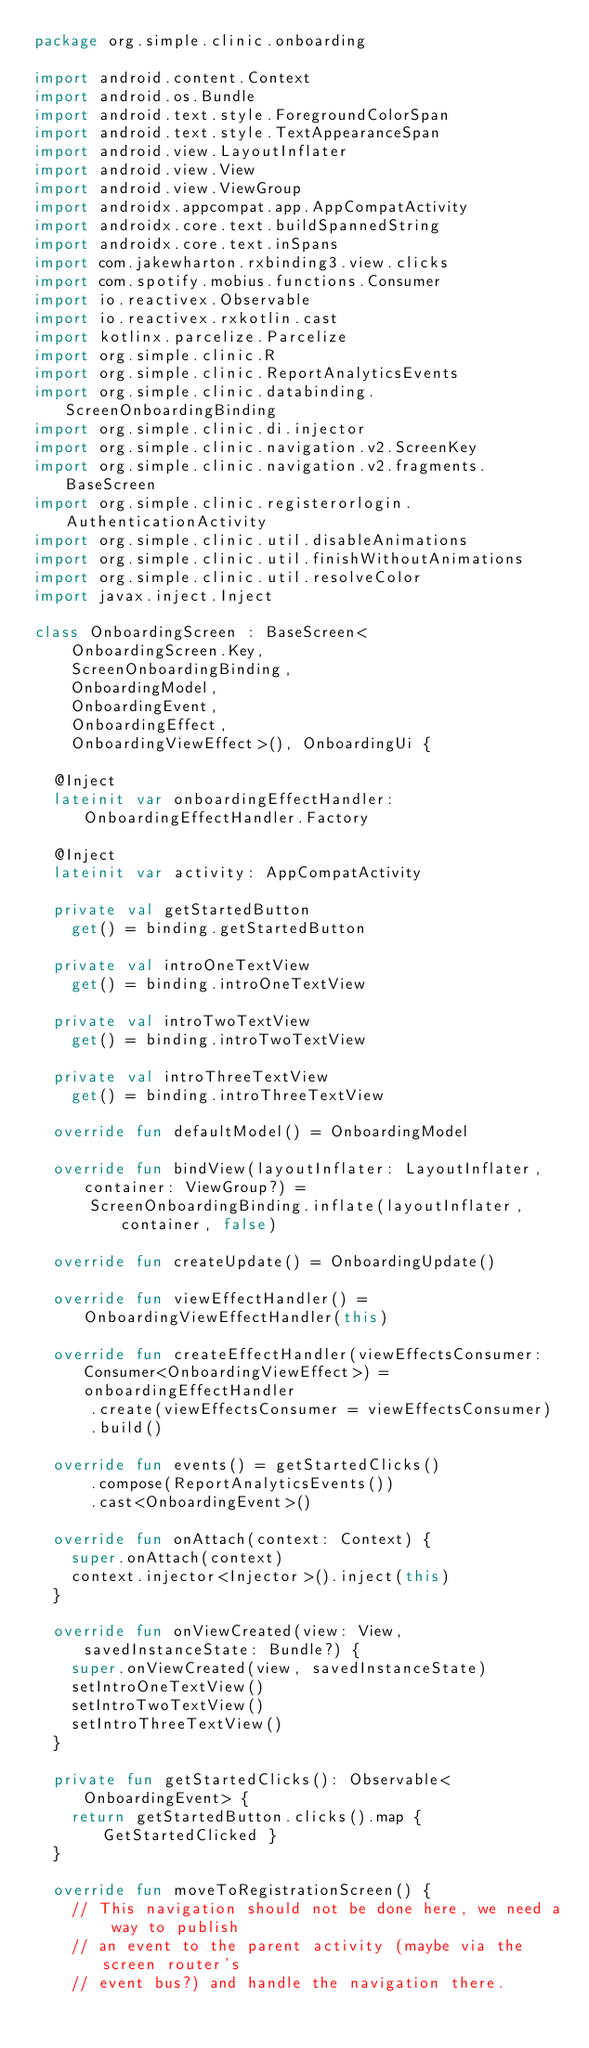Convert code to text. <code><loc_0><loc_0><loc_500><loc_500><_Kotlin_>package org.simple.clinic.onboarding

import android.content.Context
import android.os.Bundle
import android.text.style.ForegroundColorSpan
import android.text.style.TextAppearanceSpan
import android.view.LayoutInflater
import android.view.View
import android.view.ViewGroup
import androidx.appcompat.app.AppCompatActivity
import androidx.core.text.buildSpannedString
import androidx.core.text.inSpans
import com.jakewharton.rxbinding3.view.clicks
import com.spotify.mobius.functions.Consumer
import io.reactivex.Observable
import io.reactivex.rxkotlin.cast
import kotlinx.parcelize.Parcelize
import org.simple.clinic.R
import org.simple.clinic.ReportAnalyticsEvents
import org.simple.clinic.databinding.ScreenOnboardingBinding
import org.simple.clinic.di.injector
import org.simple.clinic.navigation.v2.ScreenKey
import org.simple.clinic.navigation.v2.fragments.BaseScreen
import org.simple.clinic.registerorlogin.AuthenticationActivity
import org.simple.clinic.util.disableAnimations
import org.simple.clinic.util.finishWithoutAnimations
import org.simple.clinic.util.resolveColor
import javax.inject.Inject

class OnboardingScreen : BaseScreen<
    OnboardingScreen.Key,
    ScreenOnboardingBinding,
    OnboardingModel,
    OnboardingEvent,
    OnboardingEffect,
    OnboardingViewEffect>(), OnboardingUi {

  @Inject
  lateinit var onboardingEffectHandler: OnboardingEffectHandler.Factory

  @Inject
  lateinit var activity: AppCompatActivity

  private val getStartedButton
    get() = binding.getStartedButton

  private val introOneTextView
    get() = binding.introOneTextView

  private val introTwoTextView
    get() = binding.introTwoTextView

  private val introThreeTextView
    get() = binding.introThreeTextView

  override fun defaultModel() = OnboardingModel

  override fun bindView(layoutInflater: LayoutInflater, container: ViewGroup?) =
      ScreenOnboardingBinding.inflate(layoutInflater, container, false)

  override fun createUpdate() = OnboardingUpdate()

  override fun viewEffectHandler() = OnboardingViewEffectHandler(this)

  override fun createEffectHandler(viewEffectsConsumer: Consumer<OnboardingViewEffect>) = onboardingEffectHandler
      .create(viewEffectsConsumer = viewEffectsConsumer)
      .build()

  override fun events() = getStartedClicks()
      .compose(ReportAnalyticsEvents())
      .cast<OnboardingEvent>()

  override fun onAttach(context: Context) {
    super.onAttach(context)
    context.injector<Injector>().inject(this)
  }

  override fun onViewCreated(view: View, savedInstanceState: Bundle?) {
    super.onViewCreated(view, savedInstanceState)
    setIntroOneTextView()
    setIntroTwoTextView()
    setIntroThreeTextView()
  }

  private fun getStartedClicks(): Observable<OnboardingEvent> {
    return getStartedButton.clicks().map { GetStartedClicked }
  }

  override fun moveToRegistrationScreen() {
    // This navigation should not be done here, we need a way to publish
    // an event to the parent activity (maybe via the screen router's
    // event bus?) and handle the navigation there.</code> 